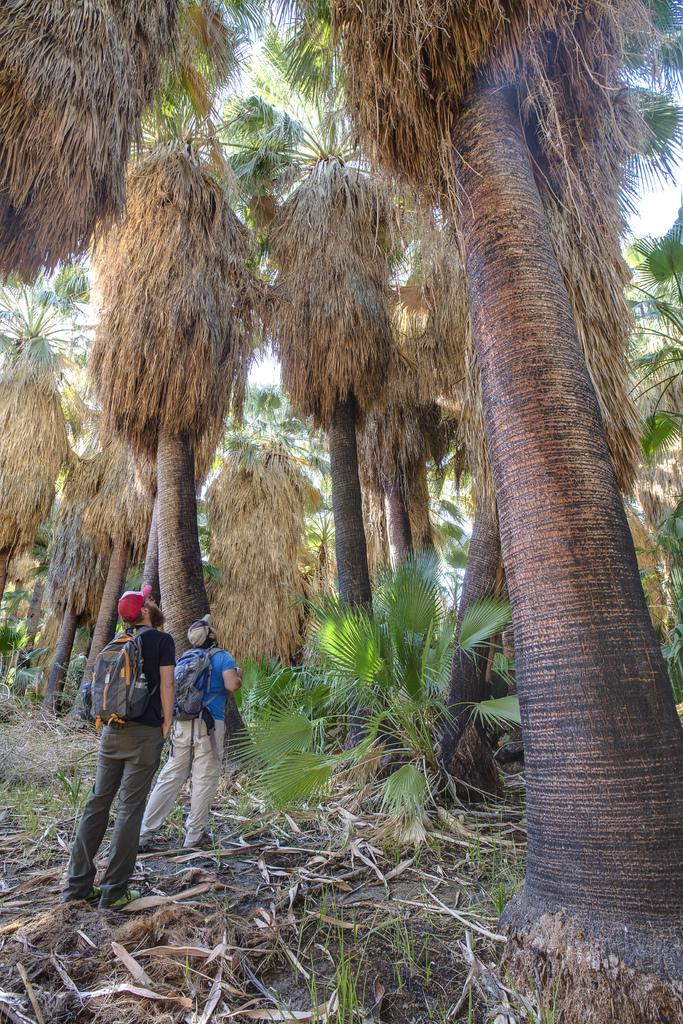Who are the people on the left side of the image? There are two people on the left side of the image. What else can be seen in the image besides the people? There are plants and trees in the image. What type of pet is sitting next to the mother in the image? There is no pet or mother present in the image; it only features two people and plants/trees. 